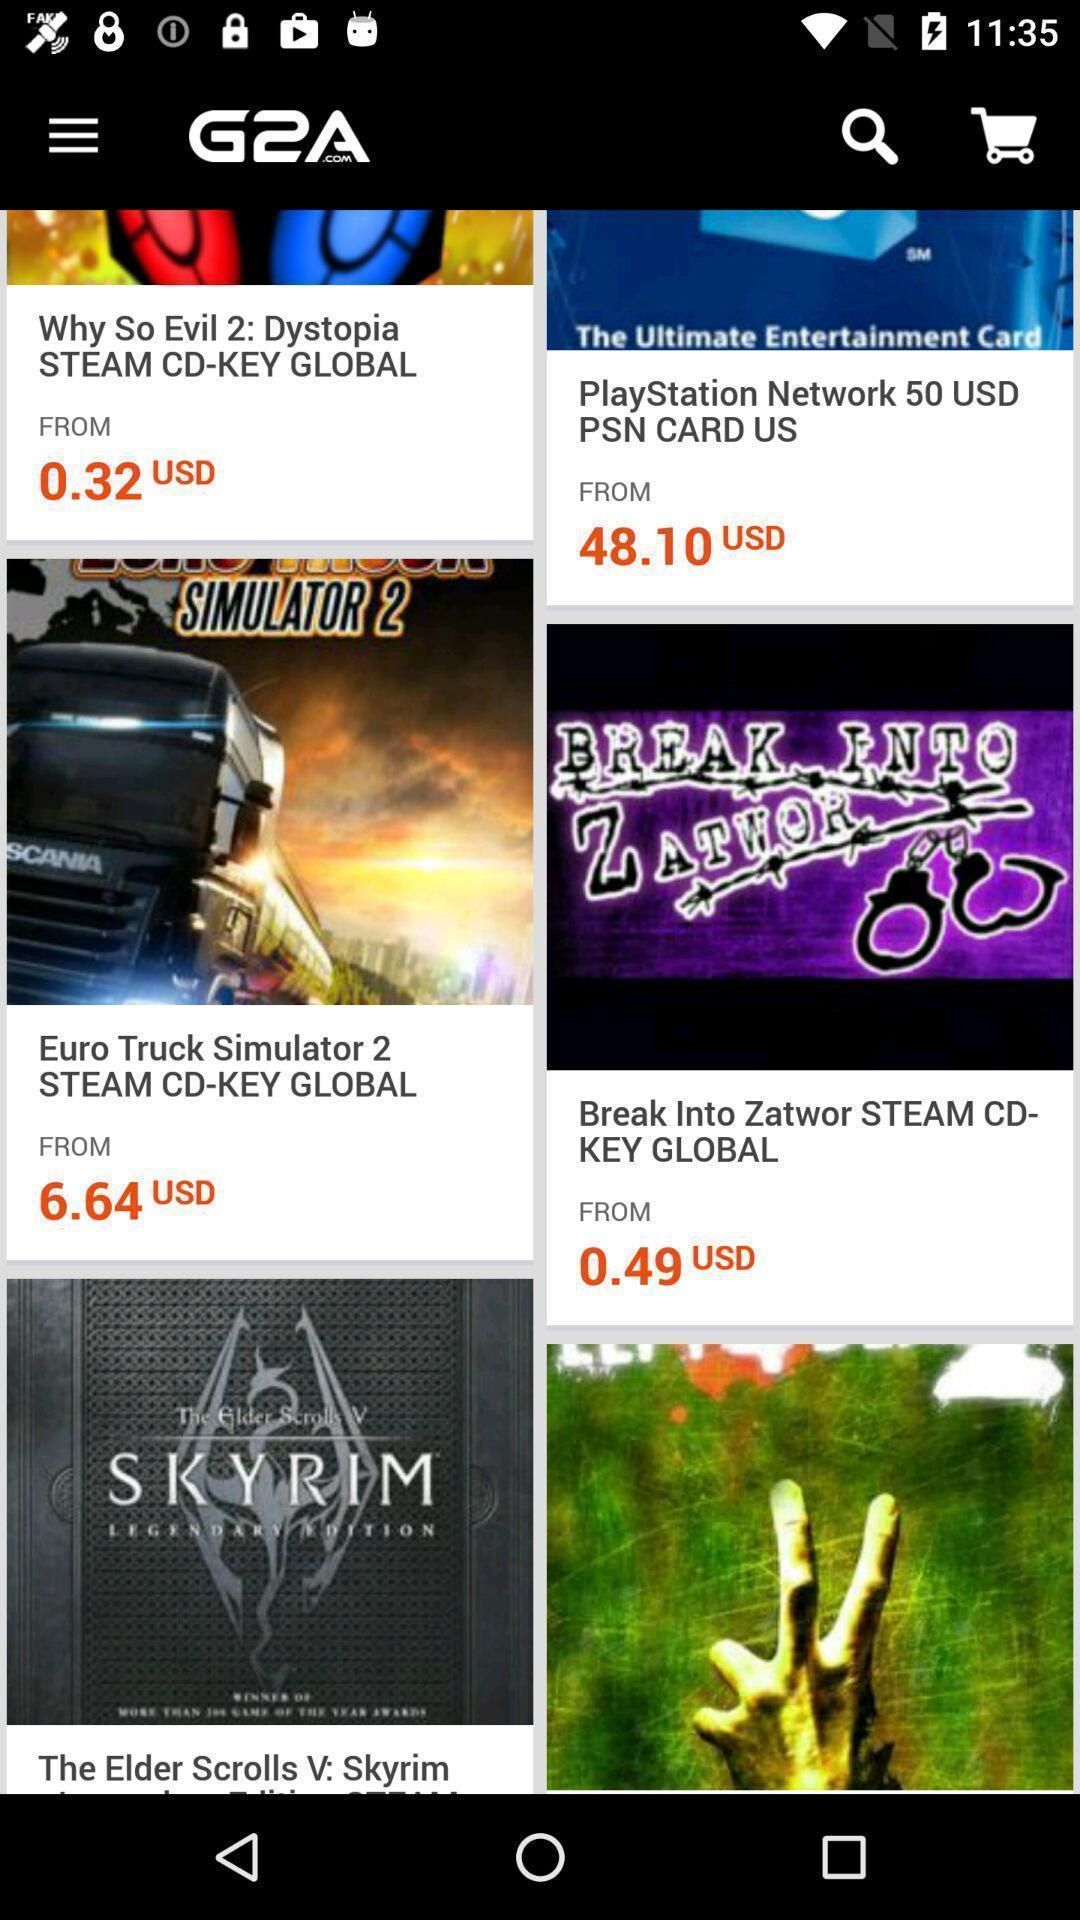Describe the content in this image. Window displaying gaming marketplace app. 